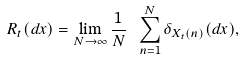Convert formula to latex. <formula><loc_0><loc_0><loc_500><loc_500>R _ { t } ( d x ) = \lim _ { N \to \infty } \frac { 1 } { N } \ \sum _ { n = 1 } ^ { N } \delta _ { X _ { t } ( n ) } ( d x ) ,</formula> 